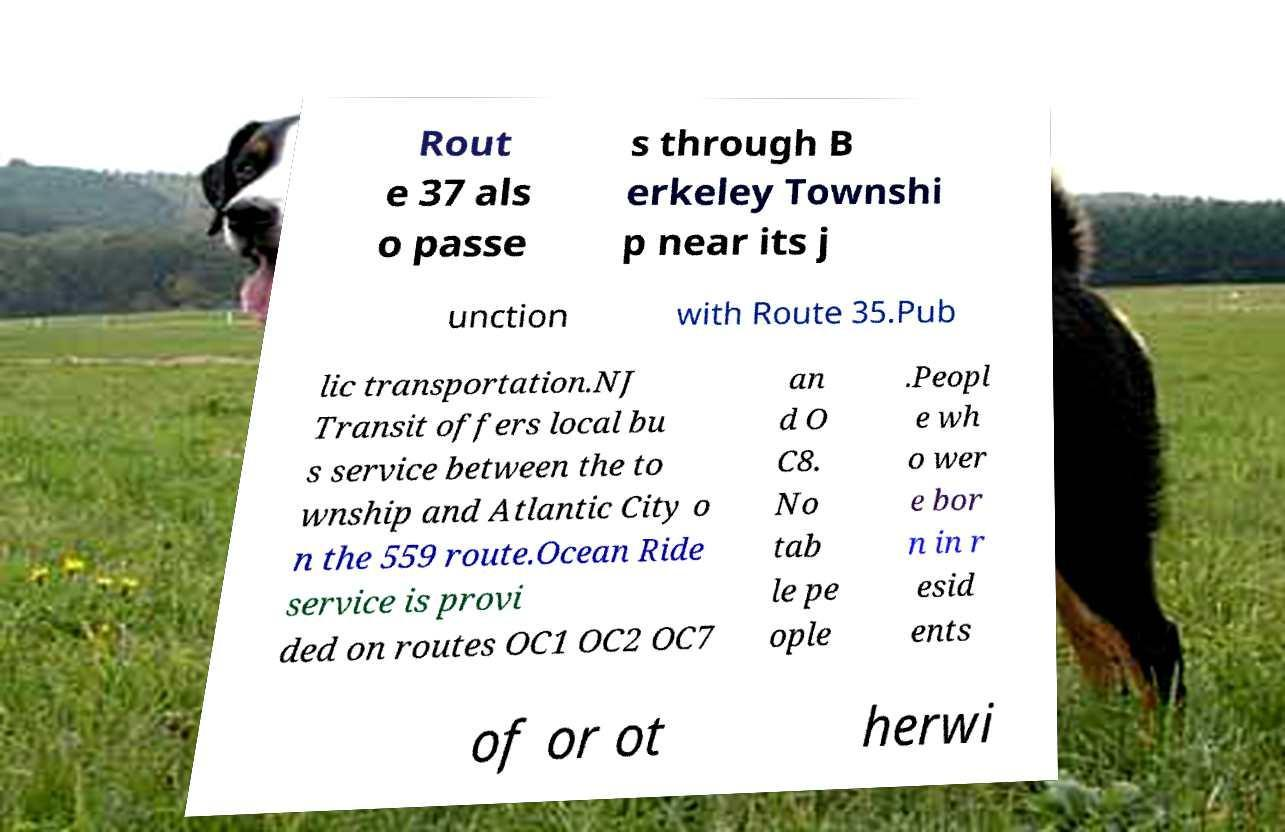What messages or text are displayed in this image? I need them in a readable, typed format. Rout e 37 als o passe s through B erkeley Townshi p near its j unction with Route 35.Pub lic transportation.NJ Transit offers local bu s service between the to wnship and Atlantic City o n the 559 route.Ocean Ride service is provi ded on routes OC1 OC2 OC7 an d O C8. No tab le pe ople .Peopl e wh o wer e bor n in r esid ents of or ot herwi 